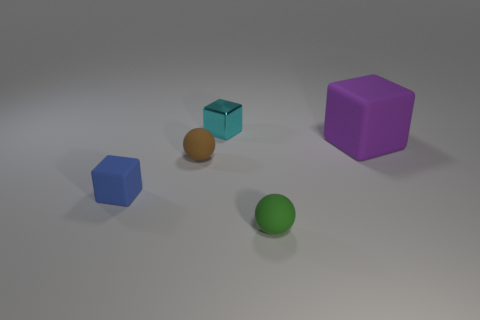There is a cyan cube that is the same size as the green matte object; what material is it?
Provide a succinct answer. Metal. What is the size of the thing that is behind the brown object and in front of the metallic block?
Keep it short and to the point. Large. There is a blue matte thing that is the same size as the green rubber ball; what shape is it?
Your answer should be very brief. Cube. The small rubber thing that is on the right side of the cyan metallic object has what shape?
Offer a terse response. Sphere. How many brown objects have the same size as the blue rubber object?
Your response must be concise. 1. What is the size of the purple rubber thing?
Offer a very short reply. Large. There is a small cyan block; how many cyan cubes are in front of it?
Provide a succinct answer. 0. There is a small green object that is made of the same material as the small brown thing; what shape is it?
Provide a short and direct response. Sphere. Are there fewer rubber blocks to the right of the large matte thing than spheres that are left of the small cyan thing?
Offer a terse response. Yes. Are there more small green rubber things than brown rubber blocks?
Your response must be concise. Yes. 